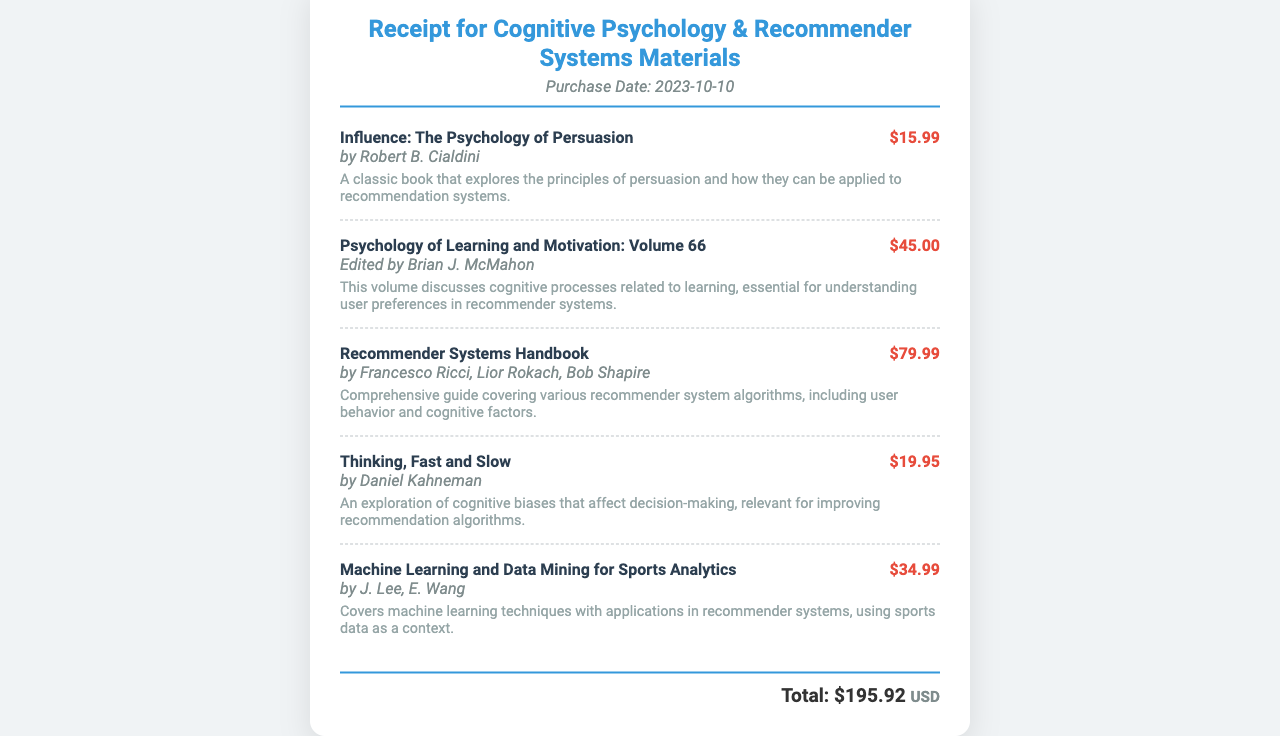What is the purchase date? The purchase date is specified in the document under the header section.
Answer: 2023-10-10 Who is the author of "Thinking, Fast and Slow"? The author of this book is mentioned below the item's title and price.
Answer: Daniel Kahneman What is the price of "Recommender Systems Handbook"? The price is displayed next to the item's title, allowing for easy retrieval of costs.
Answer: $79.99 What topic does "Psychology of Learning and Motivation: Volume 66" cover? The description provides insights into the focus of this volume, which relates to cognitive processes.
Answer: Learning How many items are listed in the receipt? The document presents individual items within a specific section, allowing for a count of the total.
Answer: 5 What is the total amount spent? The total amount spent is calculated based on the sum of individual item prices, presented at the bottom of the document.
Answer: $195.92 Which item discusses cognitive biases? The item descriptions detail content covered in each book, identifying ones related to cognitive biases.
Answer: Thinking, Fast and Slow Who edited "Psychology of Learning and Motivation: Volume 66"? The editor's name is provided in the item's author section for easy identification.
Answer: Brian J. McMahon 